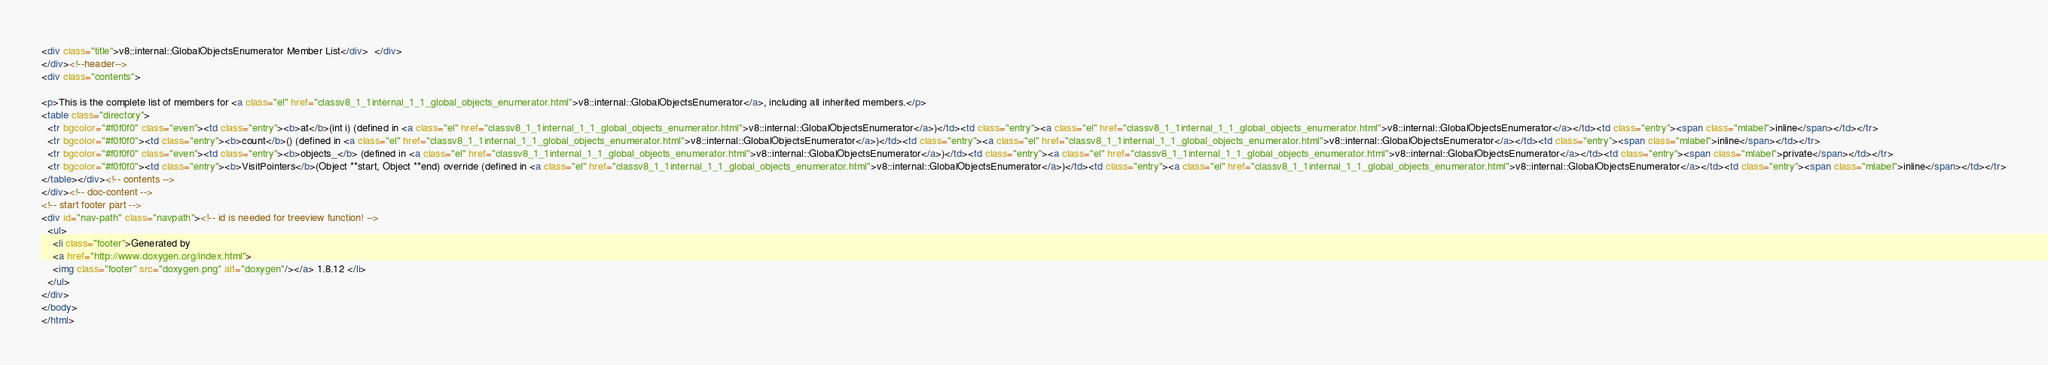<code> <loc_0><loc_0><loc_500><loc_500><_HTML_><div class="title">v8::internal::GlobalObjectsEnumerator Member List</div>  </div>
</div><!--header-->
<div class="contents">

<p>This is the complete list of members for <a class="el" href="classv8_1_1internal_1_1_global_objects_enumerator.html">v8::internal::GlobalObjectsEnumerator</a>, including all inherited members.</p>
<table class="directory">
  <tr bgcolor="#f0f0f0" class="even"><td class="entry"><b>at</b>(int i) (defined in <a class="el" href="classv8_1_1internal_1_1_global_objects_enumerator.html">v8::internal::GlobalObjectsEnumerator</a>)</td><td class="entry"><a class="el" href="classv8_1_1internal_1_1_global_objects_enumerator.html">v8::internal::GlobalObjectsEnumerator</a></td><td class="entry"><span class="mlabel">inline</span></td></tr>
  <tr bgcolor="#f0f0f0"><td class="entry"><b>count</b>() (defined in <a class="el" href="classv8_1_1internal_1_1_global_objects_enumerator.html">v8::internal::GlobalObjectsEnumerator</a>)</td><td class="entry"><a class="el" href="classv8_1_1internal_1_1_global_objects_enumerator.html">v8::internal::GlobalObjectsEnumerator</a></td><td class="entry"><span class="mlabel">inline</span></td></tr>
  <tr bgcolor="#f0f0f0" class="even"><td class="entry"><b>objects_</b> (defined in <a class="el" href="classv8_1_1internal_1_1_global_objects_enumerator.html">v8::internal::GlobalObjectsEnumerator</a>)</td><td class="entry"><a class="el" href="classv8_1_1internal_1_1_global_objects_enumerator.html">v8::internal::GlobalObjectsEnumerator</a></td><td class="entry"><span class="mlabel">private</span></td></tr>
  <tr bgcolor="#f0f0f0"><td class="entry"><b>VisitPointers</b>(Object **start, Object **end) override (defined in <a class="el" href="classv8_1_1internal_1_1_global_objects_enumerator.html">v8::internal::GlobalObjectsEnumerator</a>)</td><td class="entry"><a class="el" href="classv8_1_1internal_1_1_global_objects_enumerator.html">v8::internal::GlobalObjectsEnumerator</a></td><td class="entry"><span class="mlabel">inline</span></td></tr>
</table></div><!-- contents -->
</div><!-- doc-content -->
<!-- start footer part -->
<div id="nav-path" class="navpath"><!-- id is needed for treeview function! -->
  <ul>
    <li class="footer">Generated by
    <a href="http://www.doxygen.org/index.html">
    <img class="footer" src="doxygen.png" alt="doxygen"/></a> 1.8.12 </li>
  </ul>
</div>
</body>
</html>
</code> 